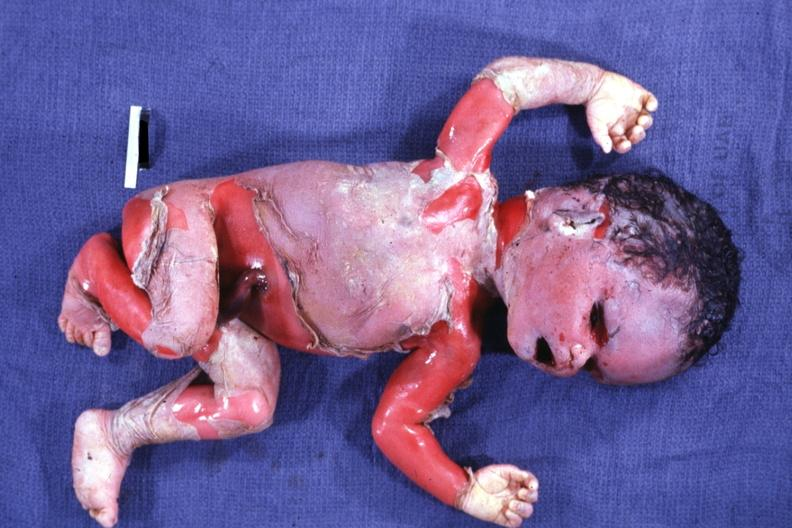what does this image show?
Answer the question using a single word or phrase. External view of advanced state 